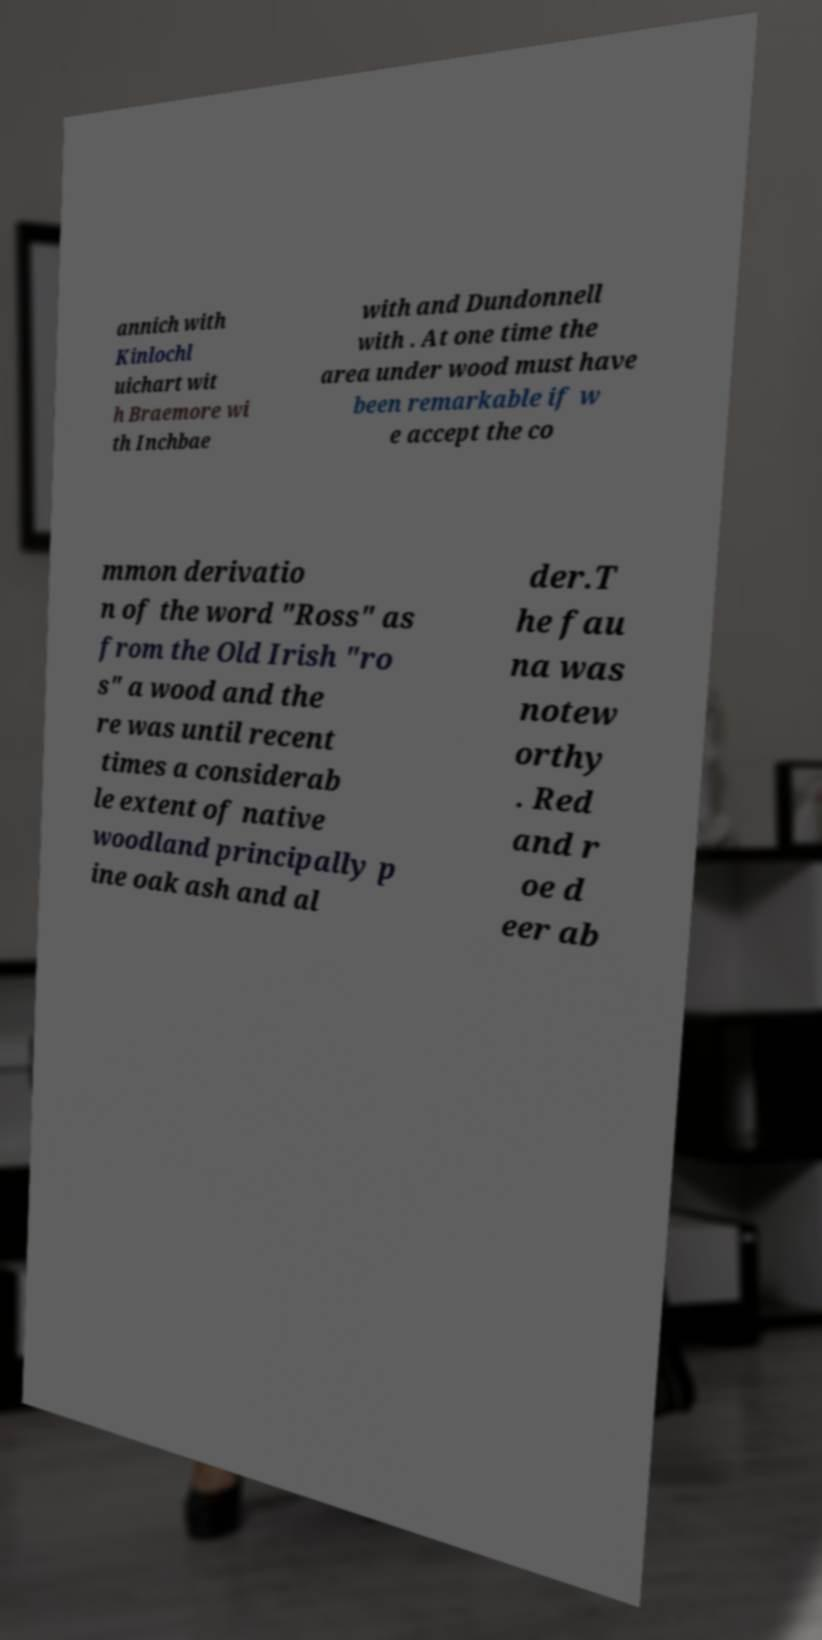Can you accurately transcribe the text from the provided image for me? annich with Kinlochl uichart wit h Braemore wi th Inchbae with and Dundonnell with . At one time the area under wood must have been remarkable if w e accept the co mmon derivatio n of the word "Ross" as from the Old Irish "ro s" a wood and the re was until recent times a considerab le extent of native woodland principally p ine oak ash and al der.T he fau na was notew orthy . Red and r oe d eer ab 